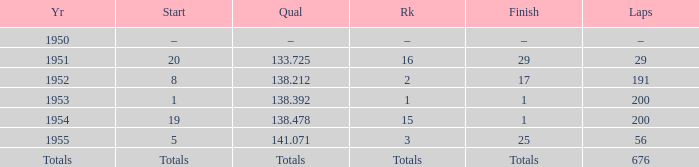How many laps does the one ranked 16 have? 29.0. 